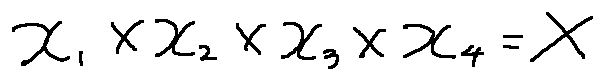Convert formula to latex. <formula><loc_0><loc_0><loc_500><loc_500>x _ { 1 } \times x _ { 2 } \times x _ { 3 } \times x _ { 4 } = X</formula> 